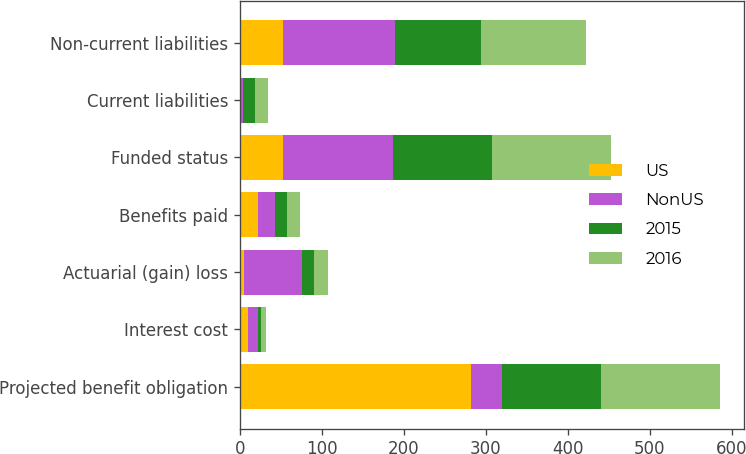Convert chart. <chart><loc_0><loc_0><loc_500><loc_500><stacked_bar_chart><ecel><fcel>Projected benefit obligation<fcel>Interest cost<fcel>Actuarial (gain) loss<fcel>Benefits paid<fcel>Funded status<fcel>Current liabilities<fcel>Non-current liabilities<nl><fcel>US<fcel>282.5<fcel>9.6<fcel>5.7<fcel>22.1<fcel>53<fcel>0.1<fcel>52.9<nl><fcel>NonUS<fcel>37.5<fcel>12.5<fcel>70.2<fcel>20.4<fcel>134.4<fcel>3.5<fcel>135.8<nl><fcel>2015<fcel>119.9<fcel>4<fcel>14.4<fcel>15.2<fcel>119.9<fcel>14.5<fcel>105.4<nl><fcel>2016<fcel>145.3<fcel>5.7<fcel>16.8<fcel>15.2<fcel>145.3<fcel>16.8<fcel>128.5<nl></chart> 